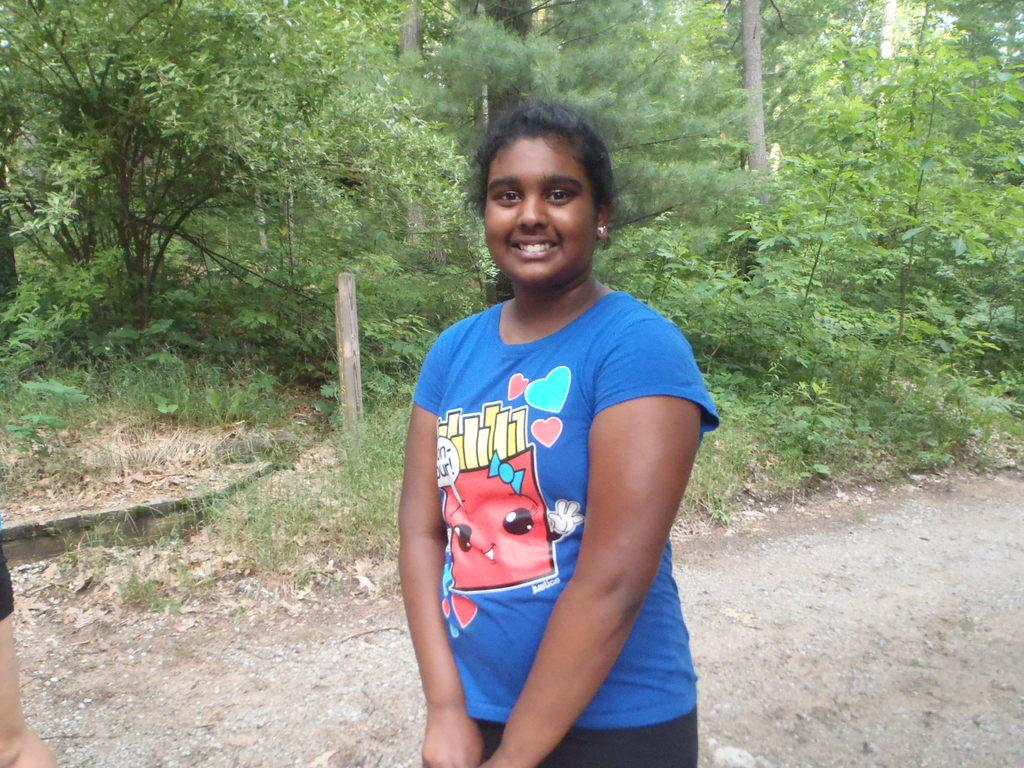What type of vegetation is present in the image? There are trees and grass in the image. What is the woman in the image wearing? The woman is wearing a blue t-shirt. What direction is the woman facing in the image? The provided facts do not mention the direction the woman is facing, so we cannot definitively answer this question. Is the woman ploughing the grass in the image? There is no indication in the image that the woman is ploughing the grass, as she is simply wearing a blue t-shirt. 